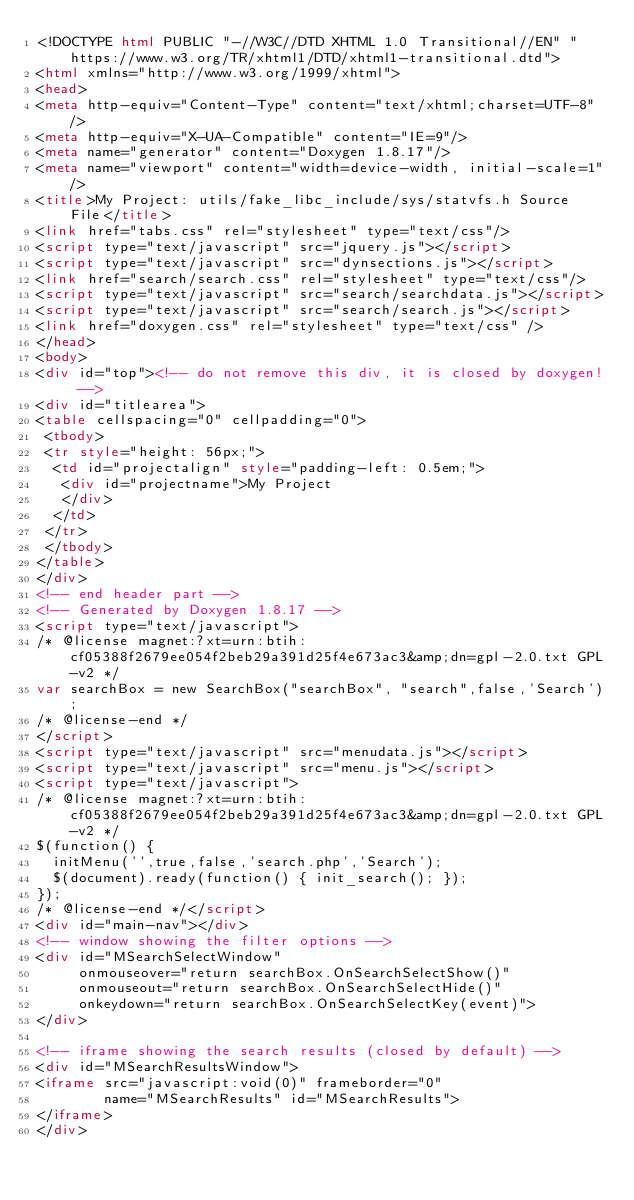Convert code to text. <code><loc_0><loc_0><loc_500><loc_500><_HTML_><!DOCTYPE html PUBLIC "-//W3C//DTD XHTML 1.0 Transitional//EN" "https://www.w3.org/TR/xhtml1/DTD/xhtml1-transitional.dtd">
<html xmlns="http://www.w3.org/1999/xhtml">
<head>
<meta http-equiv="Content-Type" content="text/xhtml;charset=UTF-8"/>
<meta http-equiv="X-UA-Compatible" content="IE=9"/>
<meta name="generator" content="Doxygen 1.8.17"/>
<meta name="viewport" content="width=device-width, initial-scale=1"/>
<title>My Project: utils/fake_libc_include/sys/statvfs.h Source File</title>
<link href="tabs.css" rel="stylesheet" type="text/css"/>
<script type="text/javascript" src="jquery.js"></script>
<script type="text/javascript" src="dynsections.js"></script>
<link href="search/search.css" rel="stylesheet" type="text/css"/>
<script type="text/javascript" src="search/searchdata.js"></script>
<script type="text/javascript" src="search/search.js"></script>
<link href="doxygen.css" rel="stylesheet" type="text/css" />
</head>
<body>
<div id="top"><!-- do not remove this div, it is closed by doxygen! -->
<div id="titlearea">
<table cellspacing="0" cellpadding="0">
 <tbody>
 <tr style="height: 56px;">
  <td id="projectalign" style="padding-left: 0.5em;">
   <div id="projectname">My Project
   </div>
  </td>
 </tr>
 </tbody>
</table>
</div>
<!-- end header part -->
<!-- Generated by Doxygen 1.8.17 -->
<script type="text/javascript">
/* @license magnet:?xt=urn:btih:cf05388f2679ee054f2beb29a391d25f4e673ac3&amp;dn=gpl-2.0.txt GPL-v2 */
var searchBox = new SearchBox("searchBox", "search",false,'Search');
/* @license-end */
</script>
<script type="text/javascript" src="menudata.js"></script>
<script type="text/javascript" src="menu.js"></script>
<script type="text/javascript">
/* @license magnet:?xt=urn:btih:cf05388f2679ee054f2beb29a391d25f4e673ac3&amp;dn=gpl-2.0.txt GPL-v2 */
$(function() {
  initMenu('',true,false,'search.php','Search');
  $(document).ready(function() { init_search(); });
});
/* @license-end */</script>
<div id="main-nav"></div>
<!-- window showing the filter options -->
<div id="MSearchSelectWindow"
     onmouseover="return searchBox.OnSearchSelectShow()"
     onmouseout="return searchBox.OnSearchSelectHide()"
     onkeydown="return searchBox.OnSearchSelectKey(event)">
</div>

<!-- iframe showing the search results (closed by default) -->
<div id="MSearchResultsWindow">
<iframe src="javascript:void(0)" frameborder="0" 
        name="MSearchResults" id="MSearchResults">
</iframe>
</div>
</code> 